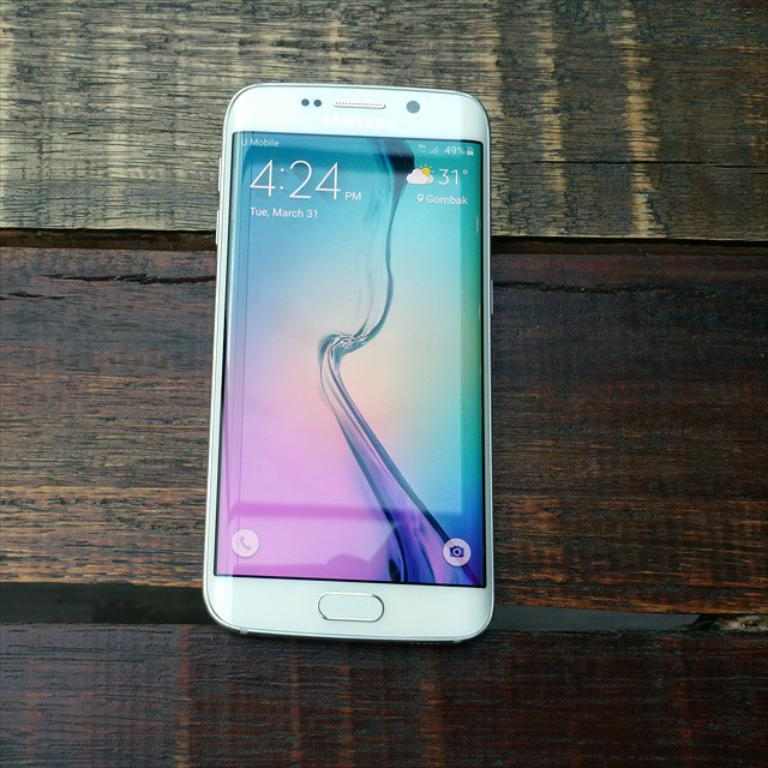What electronic device is visible in the image? There is a mobile phone in the image. What is displayed on the mobile phone's screen? The mobile phone's screen is displaying numbers and symbols. How many planes are flying over the trousers in the image? There are no planes or trousers present in the image; it only features a mobile phone with numbers and symbols on its screen. 